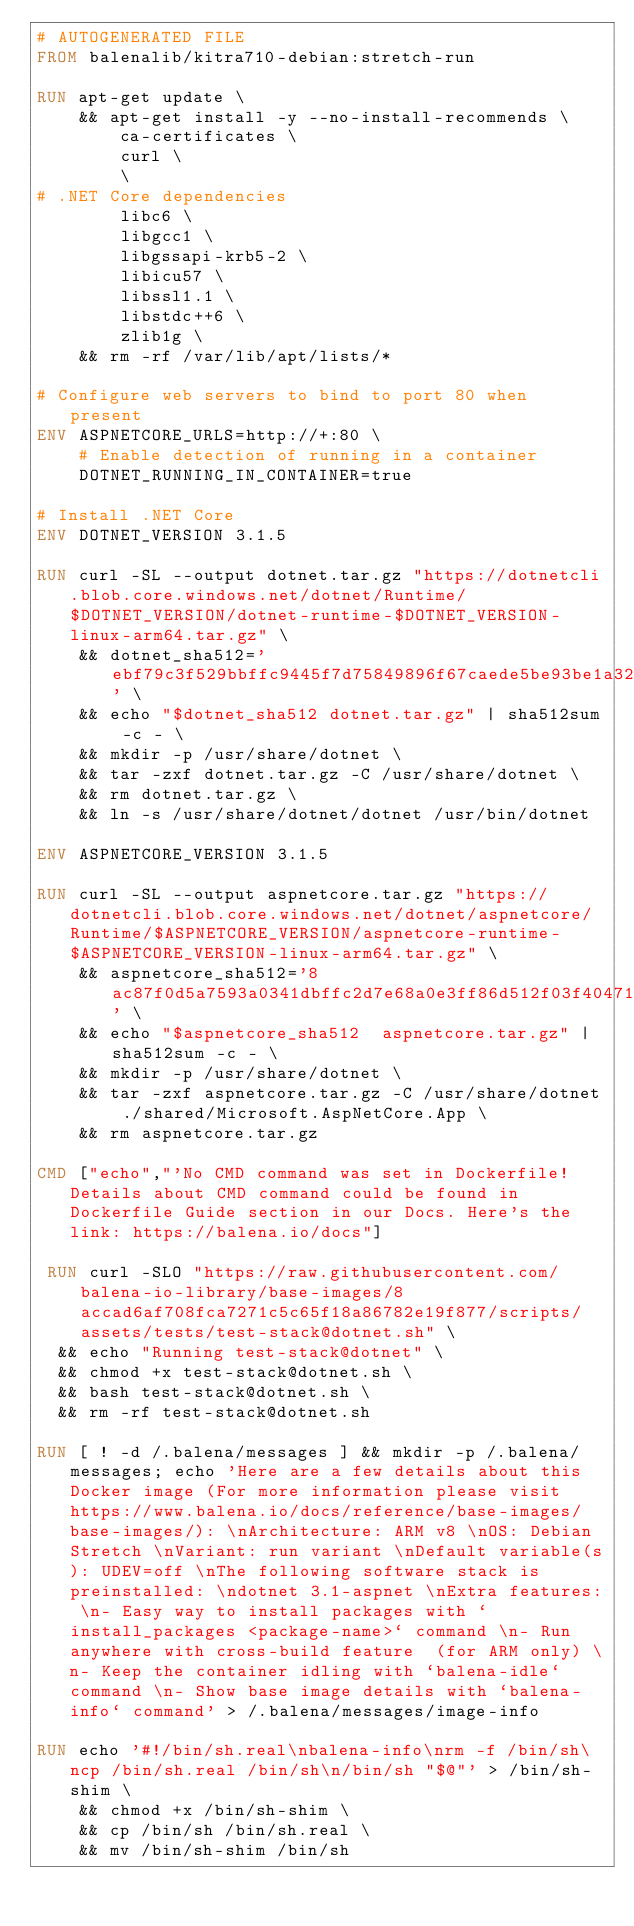<code> <loc_0><loc_0><loc_500><loc_500><_Dockerfile_># AUTOGENERATED FILE
FROM balenalib/kitra710-debian:stretch-run

RUN apt-get update \
    && apt-get install -y --no-install-recommends \
        ca-certificates \
        curl \
        \
# .NET Core dependencies
        libc6 \
        libgcc1 \
        libgssapi-krb5-2 \
        libicu57 \
        libssl1.1 \
        libstdc++6 \
        zlib1g \
    && rm -rf /var/lib/apt/lists/*

# Configure web servers to bind to port 80 when present
ENV ASPNETCORE_URLS=http://+:80 \
    # Enable detection of running in a container
    DOTNET_RUNNING_IN_CONTAINER=true

# Install .NET Core
ENV DOTNET_VERSION 3.1.5

RUN curl -SL --output dotnet.tar.gz "https://dotnetcli.blob.core.windows.net/dotnet/Runtime/$DOTNET_VERSION/dotnet-runtime-$DOTNET_VERSION-linux-arm64.tar.gz" \
    && dotnet_sha512='ebf79c3f529bbffc9445f7d75849896f67caede5be93be1a3291edb1e85120ffb35d65990cc1ed3c74bfe66627c11d93fa1283aeebbf1adc24fde1bf9545fe8a' \
    && echo "$dotnet_sha512 dotnet.tar.gz" | sha512sum -c - \
    && mkdir -p /usr/share/dotnet \
    && tar -zxf dotnet.tar.gz -C /usr/share/dotnet \
    && rm dotnet.tar.gz \
    && ln -s /usr/share/dotnet/dotnet /usr/bin/dotnet

ENV ASPNETCORE_VERSION 3.1.5

RUN curl -SL --output aspnetcore.tar.gz "https://dotnetcli.blob.core.windows.net/dotnet/aspnetcore/Runtime/$ASPNETCORE_VERSION/aspnetcore-runtime-$ASPNETCORE_VERSION-linux-arm64.tar.gz" \
    && aspnetcore_sha512='8ac87f0d5a7593a0341dbffc2d7e68a0e3ff86d512f03f40471020087152997df8176c6ea415275ed682a5fe68652e080c63f5bca6bdd10cbe76de6d086eb8ac' \
    && echo "$aspnetcore_sha512  aspnetcore.tar.gz" | sha512sum -c - \
    && mkdir -p /usr/share/dotnet \
    && tar -zxf aspnetcore.tar.gz -C /usr/share/dotnet ./shared/Microsoft.AspNetCore.App \
    && rm aspnetcore.tar.gz

CMD ["echo","'No CMD command was set in Dockerfile! Details about CMD command could be found in Dockerfile Guide section in our Docs. Here's the link: https://balena.io/docs"]

 RUN curl -SLO "https://raw.githubusercontent.com/balena-io-library/base-images/8accad6af708fca7271c5c65f18a86782e19f877/scripts/assets/tests/test-stack@dotnet.sh" \
  && echo "Running test-stack@dotnet" \
  && chmod +x test-stack@dotnet.sh \
  && bash test-stack@dotnet.sh \
  && rm -rf test-stack@dotnet.sh 

RUN [ ! -d /.balena/messages ] && mkdir -p /.balena/messages; echo 'Here are a few details about this Docker image (For more information please visit https://www.balena.io/docs/reference/base-images/base-images/): \nArchitecture: ARM v8 \nOS: Debian Stretch \nVariant: run variant \nDefault variable(s): UDEV=off \nThe following software stack is preinstalled: \ndotnet 3.1-aspnet \nExtra features: \n- Easy way to install packages with `install_packages <package-name>` command \n- Run anywhere with cross-build feature  (for ARM only) \n- Keep the container idling with `balena-idle` command \n- Show base image details with `balena-info` command' > /.balena/messages/image-info

RUN echo '#!/bin/sh.real\nbalena-info\nrm -f /bin/sh\ncp /bin/sh.real /bin/sh\n/bin/sh "$@"' > /bin/sh-shim \
	&& chmod +x /bin/sh-shim \
	&& cp /bin/sh /bin/sh.real \
	&& mv /bin/sh-shim /bin/sh</code> 